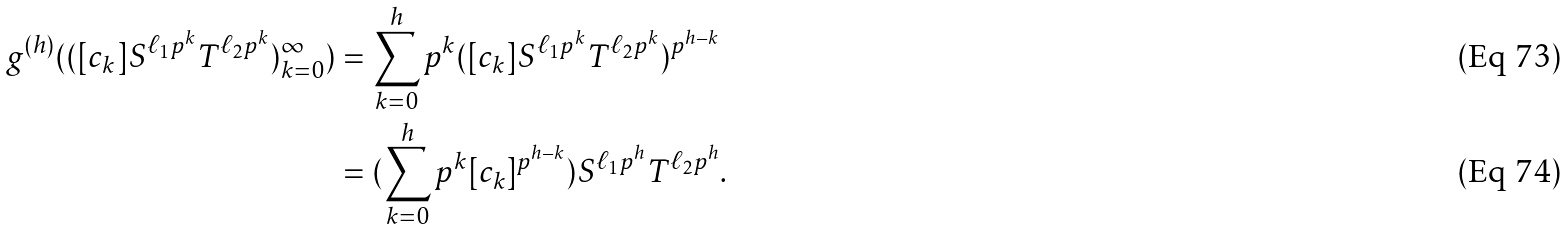Convert formula to latex. <formula><loc_0><loc_0><loc_500><loc_500>g ^ { ( h ) } ( { ( [ c _ { k } ] S ^ { \ell _ { 1 } p ^ { k } } T ^ { \ell _ { 2 } p ^ { k } } ) _ { k = 0 } ^ { \infty } } ) & = \sum _ { k = 0 } ^ { h } p ^ { k } ( [ c _ { k } ] S ^ { \ell _ { 1 } p ^ { k } } T ^ { \ell _ { 2 } p ^ { k } } ) ^ { p ^ { h - k } } \\ & = ( \sum _ { k = 0 } ^ { h } p ^ { k } [ c _ { k } ] ^ { p ^ { h - k } } ) S ^ { \ell _ { 1 } p ^ { h } } T ^ { \ell _ { 2 } p ^ { h } } .</formula> 